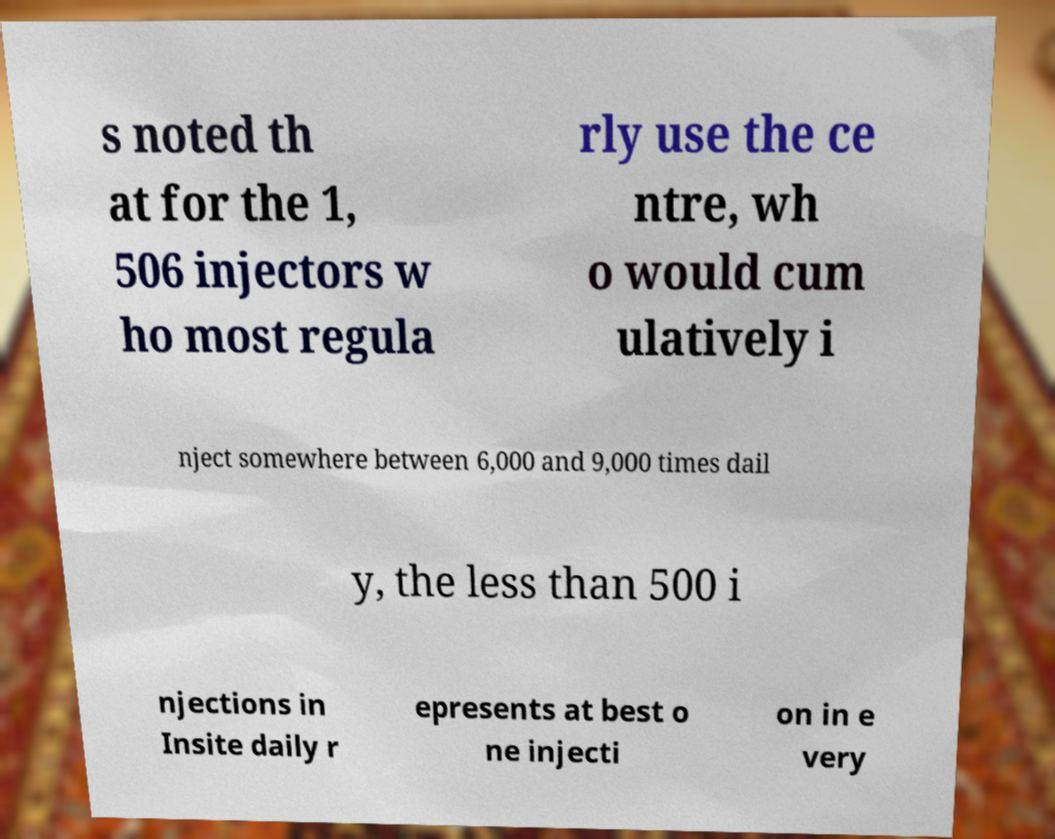There's text embedded in this image that I need extracted. Can you transcribe it verbatim? s noted th at for the 1, 506 injectors w ho most regula rly use the ce ntre, wh o would cum ulatively i nject somewhere between 6,000 and 9,000 times dail y, the less than 500 i njections in Insite daily r epresents at best o ne injecti on in e very 